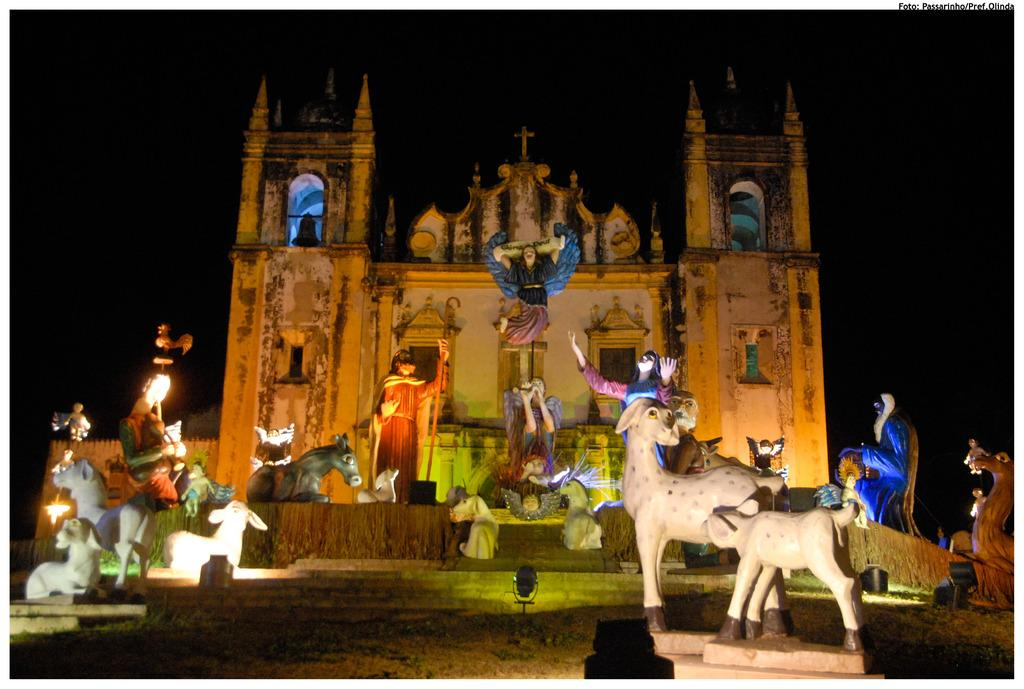What types of statues can be seen in the image? There are statues of persons and animals in the image. How are the statues arranged in the image? The statues are arranged on a platform. What can be seen in the background of the image? There is a building in the background of the image. What is the color of the background in the image? The background of the image is dark in color. What type of stove is visible in the image? There is no stove present in the image. What date is shown on the calendar in the image? There is no calendar present in the image. 